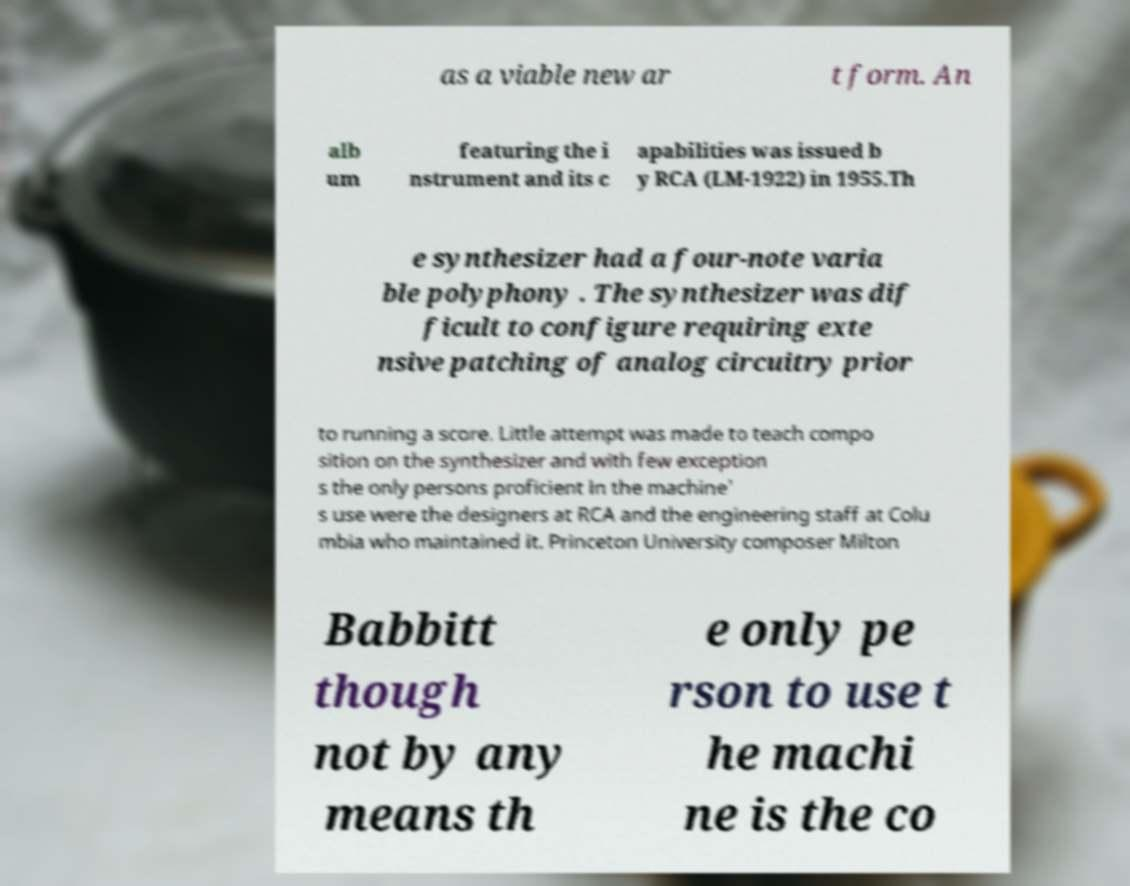Could you extract and type out the text from this image? as a viable new ar t form. An alb um featuring the i nstrument and its c apabilities was issued b y RCA (LM-1922) in 1955.Th e synthesizer had a four-note varia ble polyphony . The synthesizer was dif ficult to configure requiring exte nsive patching of analog circuitry prior to running a score. Little attempt was made to teach compo sition on the synthesizer and with few exception s the only persons proficient in the machine' s use were the designers at RCA and the engineering staff at Colu mbia who maintained it. Princeton University composer Milton Babbitt though not by any means th e only pe rson to use t he machi ne is the co 